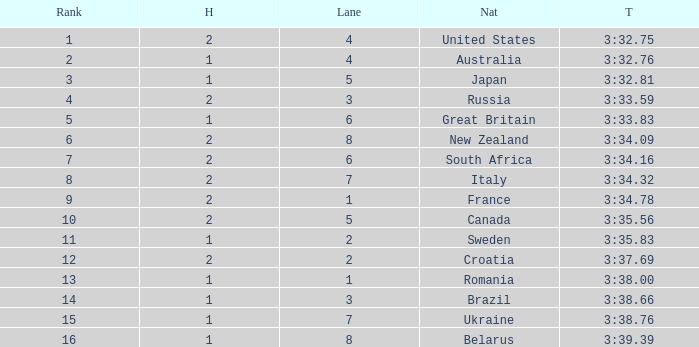Can you tell me the Rank that has the Lane of 6, and the Heat of 2? 7.0. 